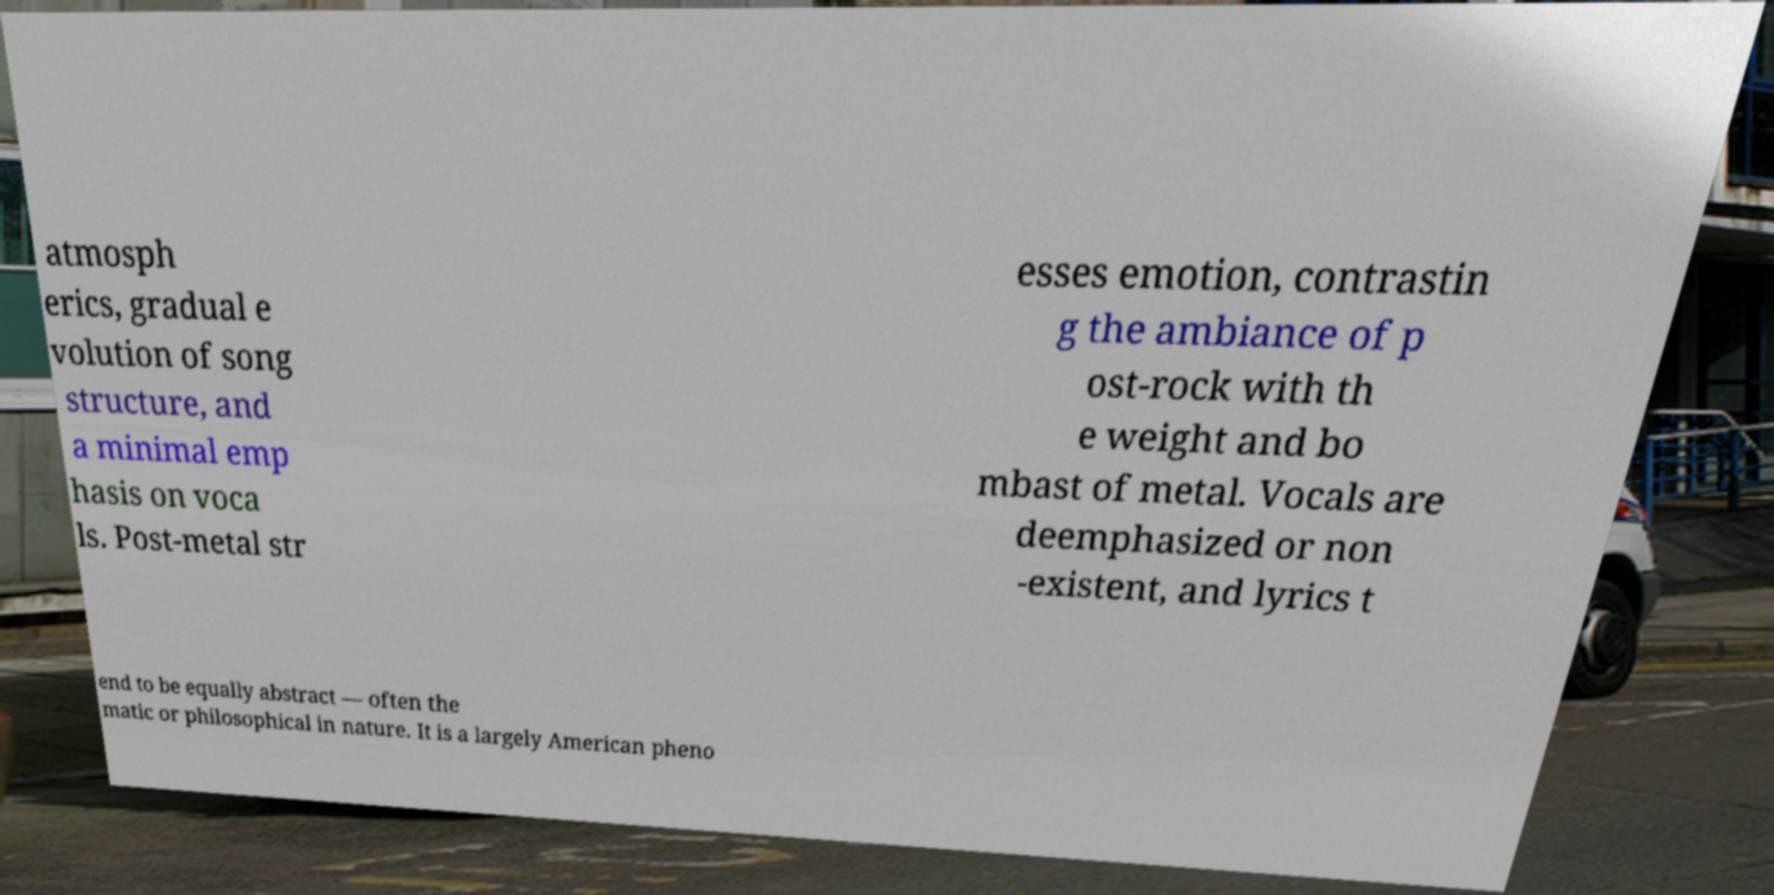Please read and relay the text visible in this image. What does it say? atmosph erics, gradual e volution of song structure, and a minimal emp hasis on voca ls. Post-metal str esses emotion, contrastin g the ambiance of p ost-rock with th e weight and bo mbast of metal. Vocals are deemphasized or non -existent, and lyrics t end to be equally abstract — often the matic or philosophical in nature. It is a largely American pheno 